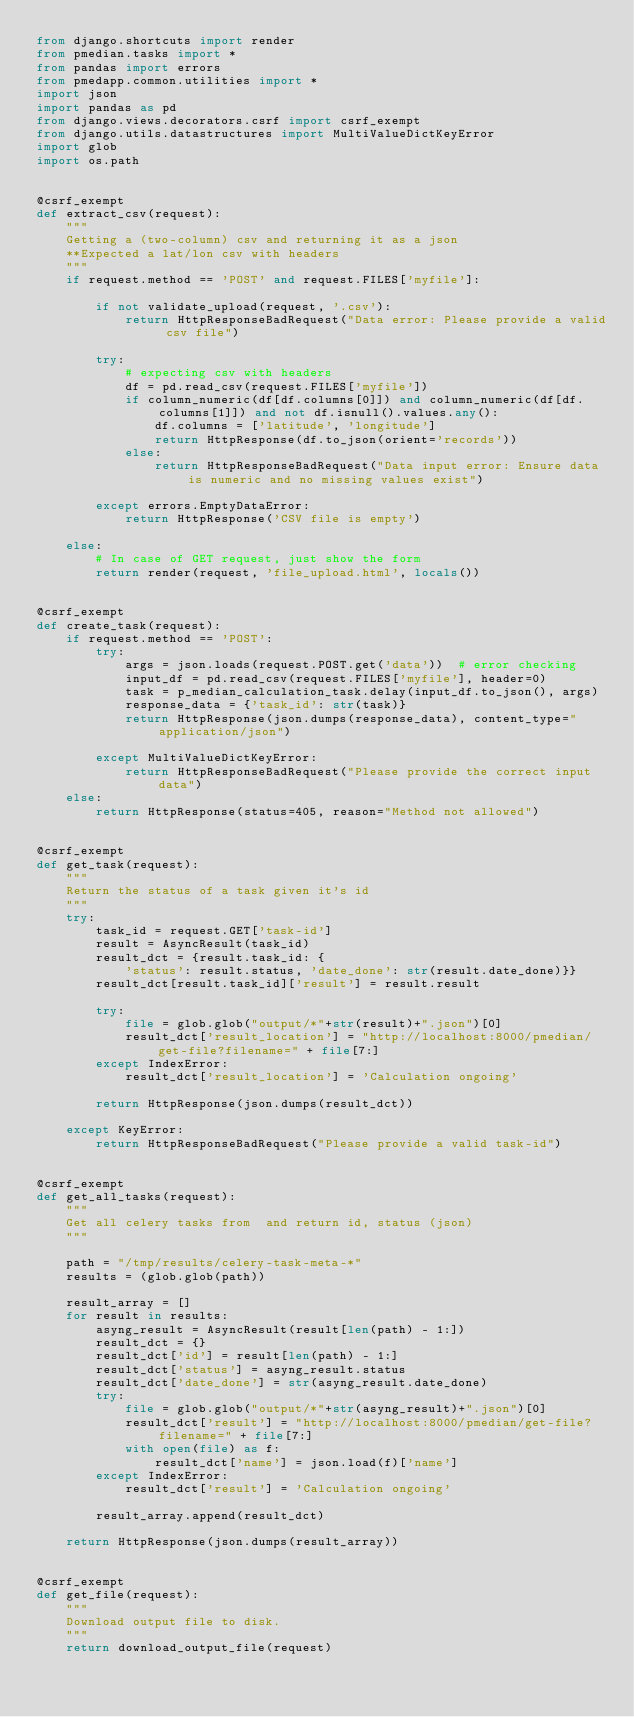Convert code to text. <code><loc_0><loc_0><loc_500><loc_500><_Python_>from django.shortcuts import render
from pmedian.tasks import *
from pandas import errors
from pmedapp.common.utilities import *
import json
import pandas as pd
from django.views.decorators.csrf import csrf_exempt
from django.utils.datastructures import MultiValueDictKeyError
import glob
import os.path


@csrf_exempt
def extract_csv(request):
    """
    Getting a (two-column) csv and returning it as a json
    **Expected a lat/lon csv with headers
    """
    if request.method == 'POST' and request.FILES['myfile']:

        if not validate_upload(request, '.csv'):
            return HttpResponseBadRequest("Data error: Please provide a valid csv file")

        try:
            # expecting csv with headers
            df = pd.read_csv(request.FILES['myfile'])
            if column_numeric(df[df.columns[0]]) and column_numeric(df[df.columns[1]]) and not df.isnull().values.any():
                df.columns = ['latitude', 'longitude']
                return HttpResponse(df.to_json(orient='records'))
            else:
                return HttpResponseBadRequest("Data input error: Ensure data is numeric and no missing values exist")

        except errors.EmptyDataError:
            return HttpResponse('CSV file is empty')

    else:
        # In case of GET request, just show the form
        return render(request, 'file_upload.html', locals())


@csrf_exempt
def create_task(request):
    if request.method == 'POST':
        try:
            args = json.loads(request.POST.get('data'))  # error checking
            input_df = pd.read_csv(request.FILES['myfile'], header=0)
            task = p_median_calculation_task.delay(input_df.to_json(), args)
            response_data = {'task_id': str(task)}
            return HttpResponse(json.dumps(response_data), content_type="application/json")

        except MultiValueDictKeyError:
            return HttpResponseBadRequest("Please provide the correct input data")
    else:
        return HttpResponse(status=405, reason="Method not allowed")


@csrf_exempt
def get_task(request):
    """
    Return the status of a task given it's id
    """
    try:
        task_id = request.GET['task-id']
        result = AsyncResult(task_id)
        result_dct = {result.task_id: {
            'status': result.status, 'date_done': str(result.date_done)}}
        result_dct[result.task_id]['result'] = result.result

        try:
            file = glob.glob("output/*"+str(result)+".json")[0]
            result_dct['result_location'] = "http://localhost:8000/pmedian/get-file?filename=" + file[7:]
        except IndexError:
            result_dct['result_location'] = 'Calculation ongoing'

        return HttpResponse(json.dumps(result_dct))

    except KeyError:
        return HttpResponseBadRequest("Please provide a valid task-id")


@csrf_exempt
def get_all_tasks(request):
    """
    Get all celery tasks from  and return id, status (json)
    """

    path = "/tmp/results/celery-task-meta-*"
    results = (glob.glob(path))

    result_array = []
    for result in results:
        asyng_result = AsyncResult(result[len(path) - 1:])
        result_dct = {}
        result_dct['id'] = result[len(path) - 1:]
        result_dct['status'] = asyng_result.status
        result_dct['date_done'] = str(asyng_result.date_done)
        try:
            file = glob.glob("output/*"+str(asyng_result)+".json")[0]
            result_dct['result'] = "http://localhost:8000/pmedian/get-file?filename=" + file[7:]
            with open(file) as f:
                result_dct['name'] = json.load(f)['name']
        except IndexError:
            result_dct['result'] = 'Calculation ongoing'

        result_array.append(result_dct)

    return HttpResponse(json.dumps(result_array))


@csrf_exempt
def get_file(request):
    """
    Download output file to disk.
    """
    return download_output_file(request)
</code> 